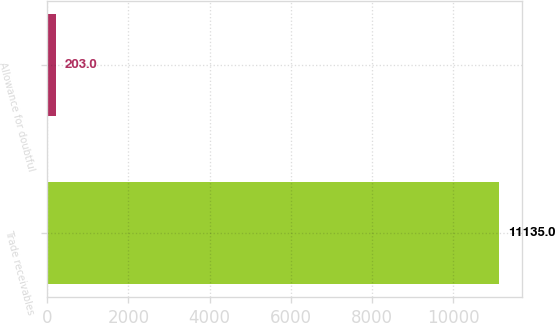Convert chart. <chart><loc_0><loc_0><loc_500><loc_500><bar_chart><fcel>Trade receivables<fcel>Allowance for doubtful<nl><fcel>11135<fcel>203<nl></chart> 